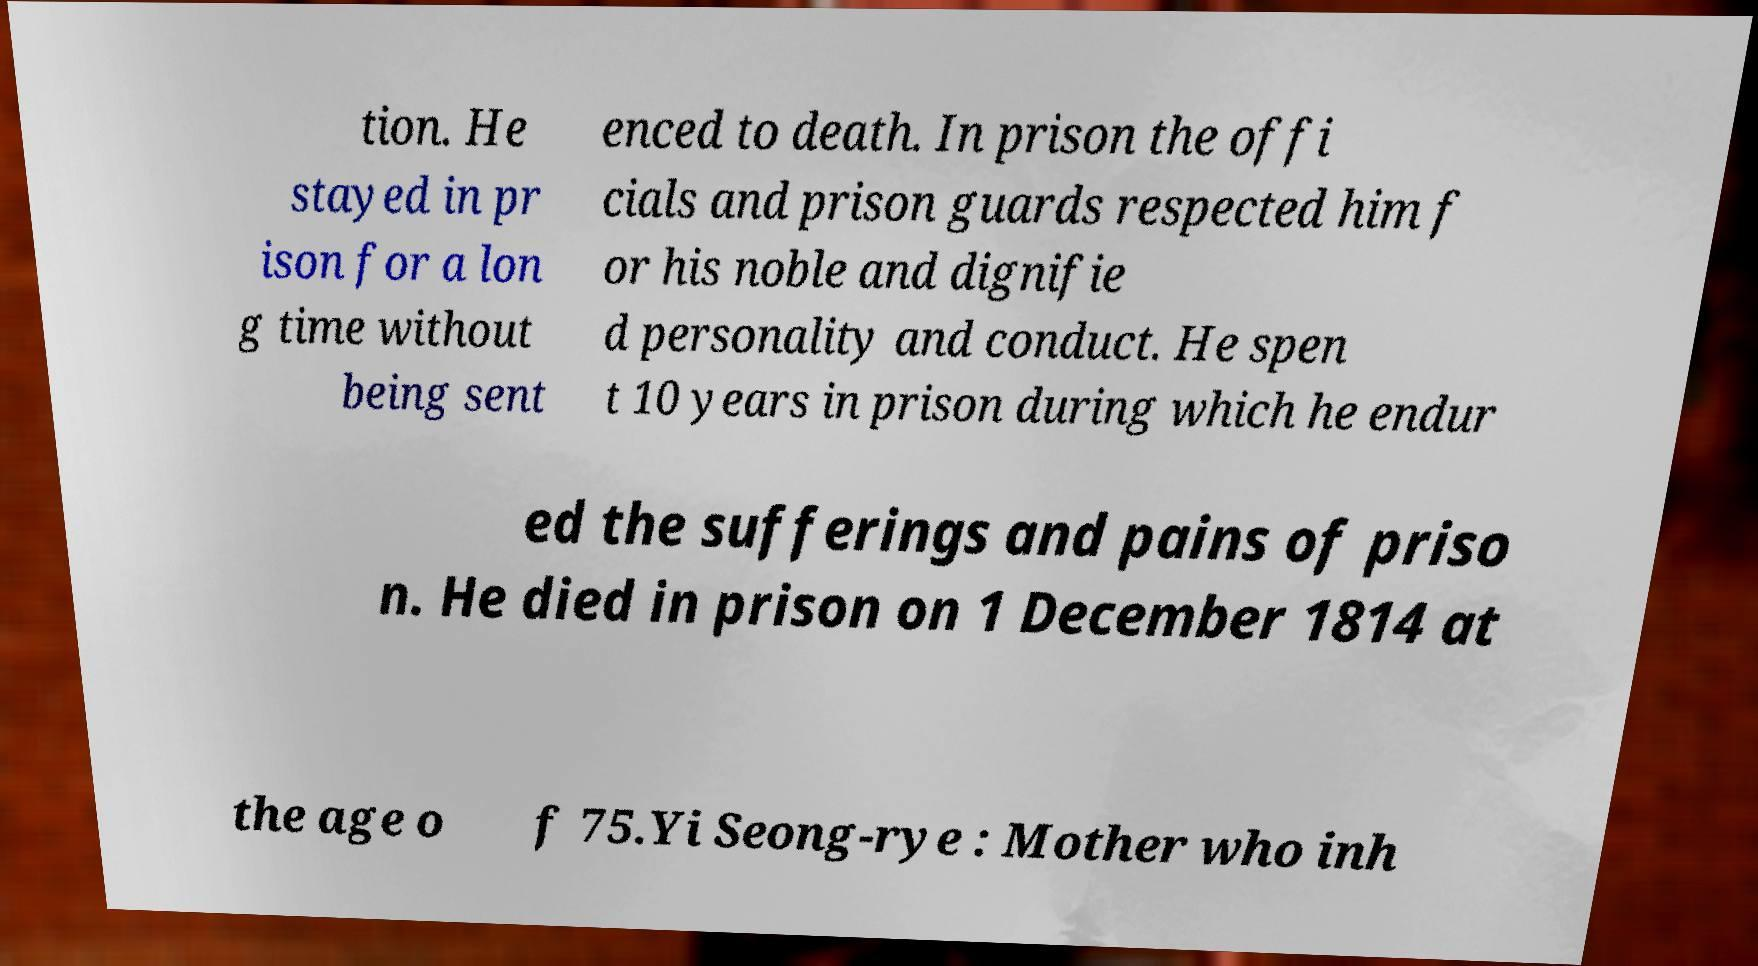Can you read and provide the text displayed in the image?This photo seems to have some interesting text. Can you extract and type it out for me? tion. He stayed in pr ison for a lon g time without being sent enced to death. In prison the offi cials and prison guards respected him f or his noble and dignifie d personality and conduct. He spen t 10 years in prison during which he endur ed the sufferings and pains of priso n. He died in prison on 1 December 1814 at the age o f 75.Yi Seong-rye : Mother who inh 